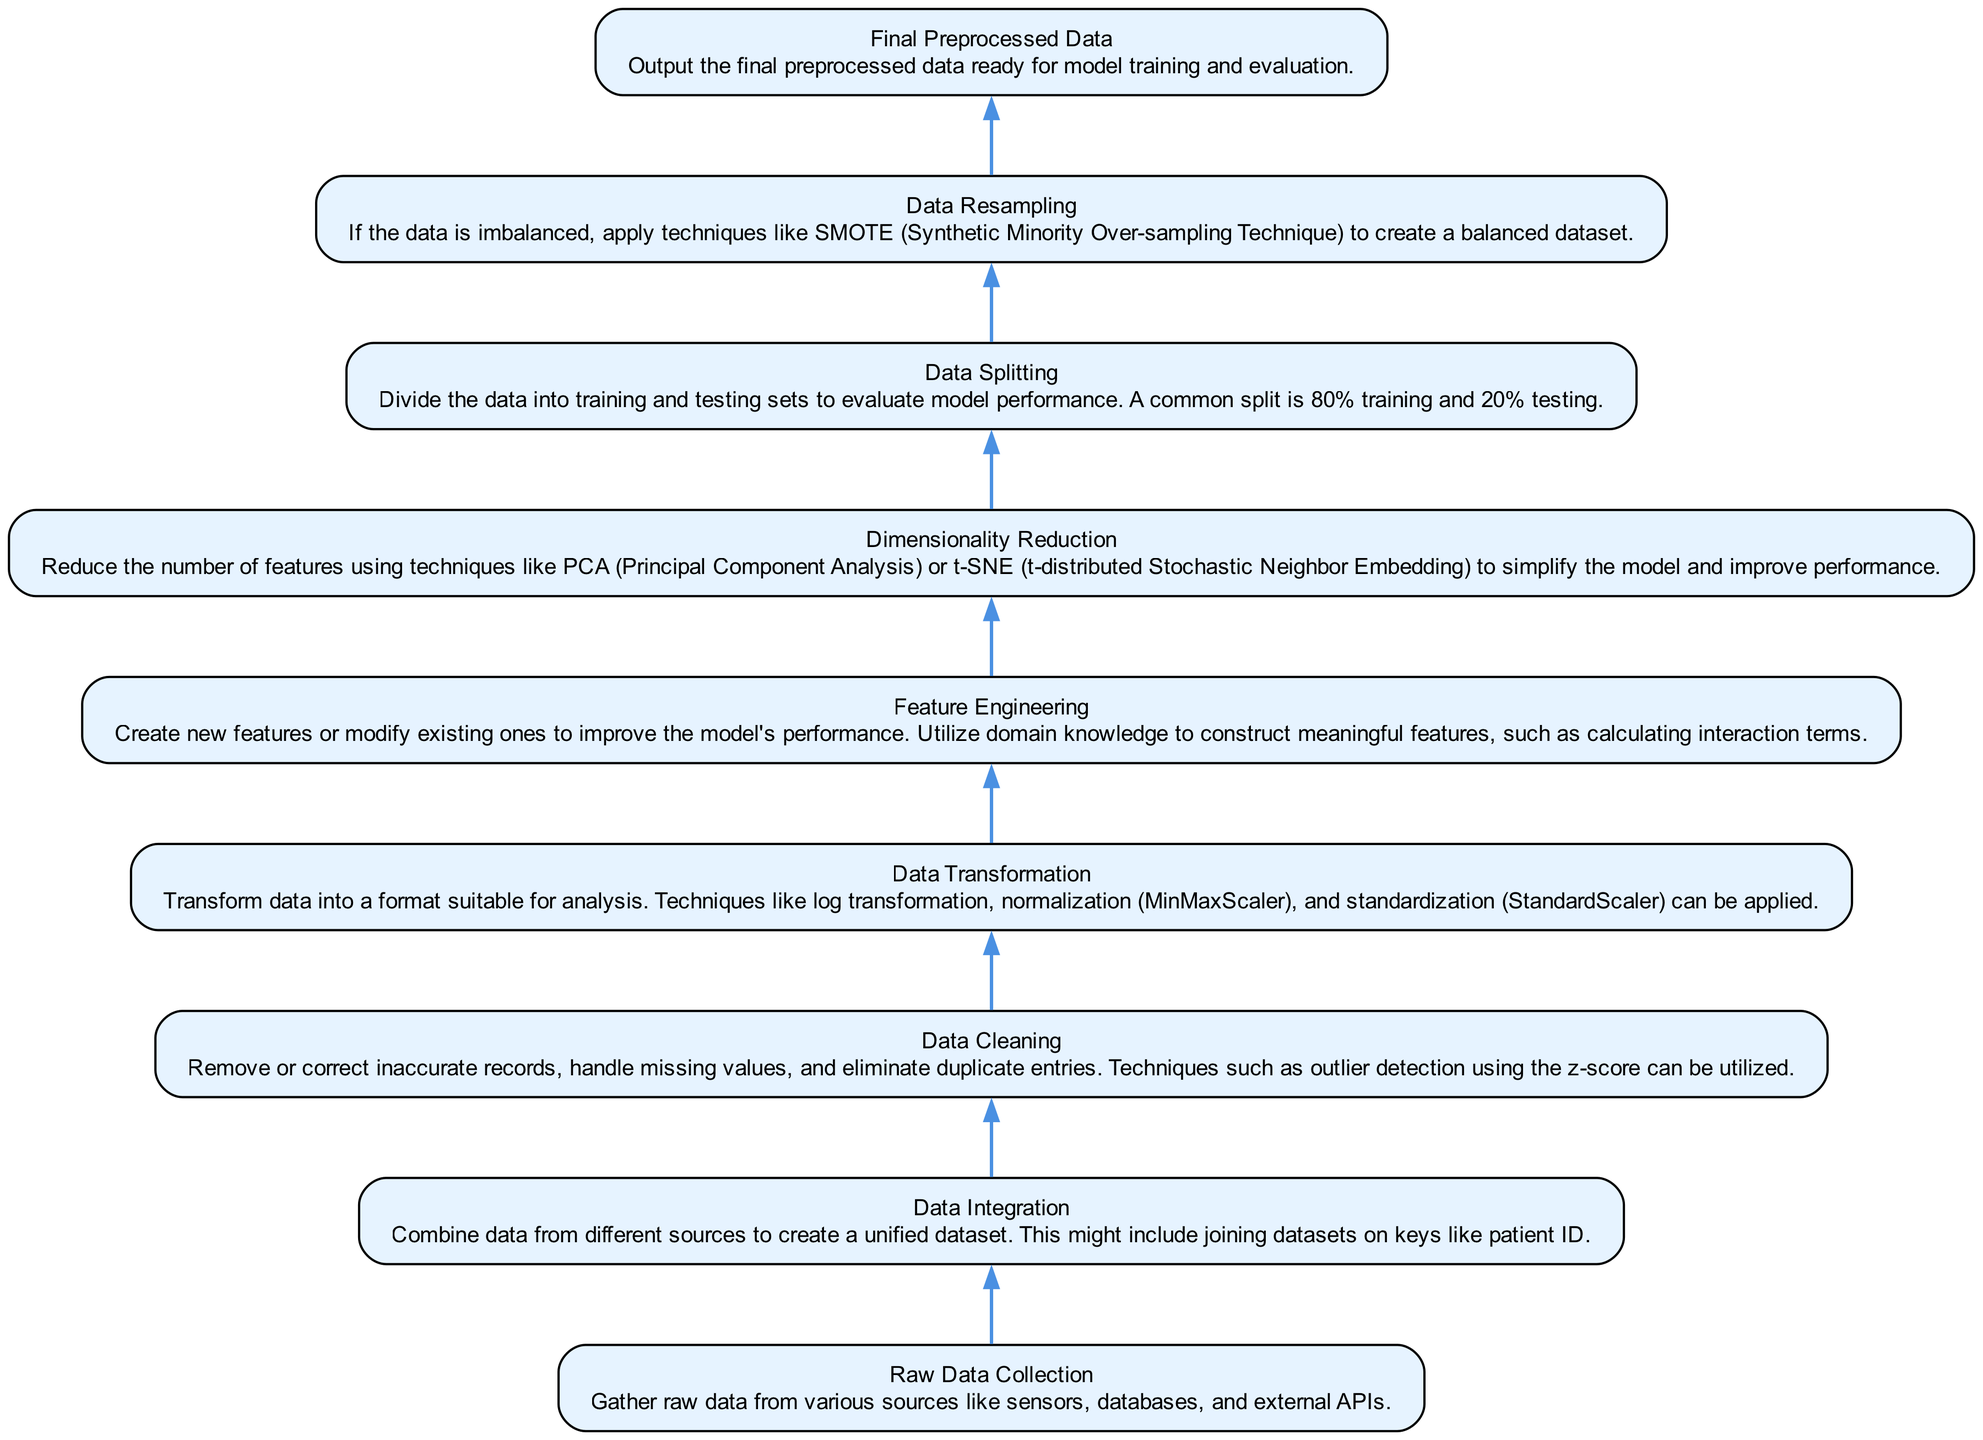What is the first step in the data preprocessing pipeline? The diagram indicates that "Raw Data Collection" is the first step, visually positioned at the bottom of the flow chart.
Answer: Raw Data Collection How many nodes are present in the diagram? By counting the labeled sections in the flow chart, there are a total of nine nodes representing each stage of the data preprocessing pipeline.
Answer: Nine What node follows "Data Cleaning"? Looking at the flow direction of the chart, "Data Transformation" is the next node that occurs directly after "Data Cleaning."
Answer: Data Transformation In which step do we balance the dataset? The diagram clearly shows that "Data Resampling," following "Data Splitting," is the step designed to address dataset imbalance.
Answer: Data Resampling Which nodes are involved in transforming data? The transformation process is indicated by "Data Transformation" and also incorporates "Feature Engineering" and "Dimensionality Reduction," as these steps modify data for analytical purposes.
Answer: Data Transformation, Feature Engineering, Dimensionality Reduction Which step directly produces the final output? The last node in the flow chart is "Final Preprocessed Data," which represents the ultimate output of the entire preprocessing pipeline, confirming that the previous steps culminate here.
Answer: Final Preprocessed Data What is the primary purpose of "Feature Engineering"? According to the description adjacent to the node, "Feature Engineering" is primarily to create new features or adjust existing ones to enhance the model's performance.
Answer: Improve model performance Which technique is mentioned for handling missing data during "Data Cleaning"? The flow chart indicates that outlier detection using the z-score method can be employed as part of the strategies to manage inaccurate records and missing values in "Data Cleaning."
Answer: Outlier detection using z-score What is the last summarizing activity before the model training? The diagram illustrates that "Final Preprocessed Data" is the concluding step, which yields the processed dataset that is ready for model training and evaluation.
Answer: Final Preprocessed Data 